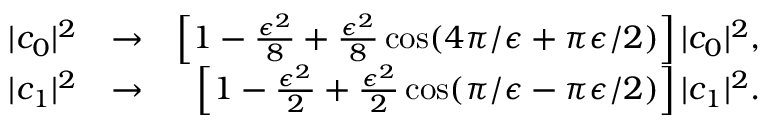<formula> <loc_0><loc_0><loc_500><loc_500>\begin{array} { r l r } { | c _ { 0 } | ^ { 2 } } & { \rightarrow } & { \left [ 1 - \frac { \epsilon ^ { 2 } } { 8 } + \frac { \epsilon ^ { 2 } } { 8 } \cos ( 4 \pi / \epsilon + \pi \epsilon / 2 ) \right ] | c _ { 0 } | ^ { 2 } , } \\ { | c _ { 1 } | ^ { 2 } } & { \rightarrow } & { \left [ 1 - \frac { \epsilon ^ { 2 } } { 2 } + \frac { \epsilon ^ { 2 } } { 2 } \cos ( \pi / \epsilon - \pi \epsilon / 2 ) \right ] | c _ { 1 } | ^ { 2 } . } \end{array}</formula> 